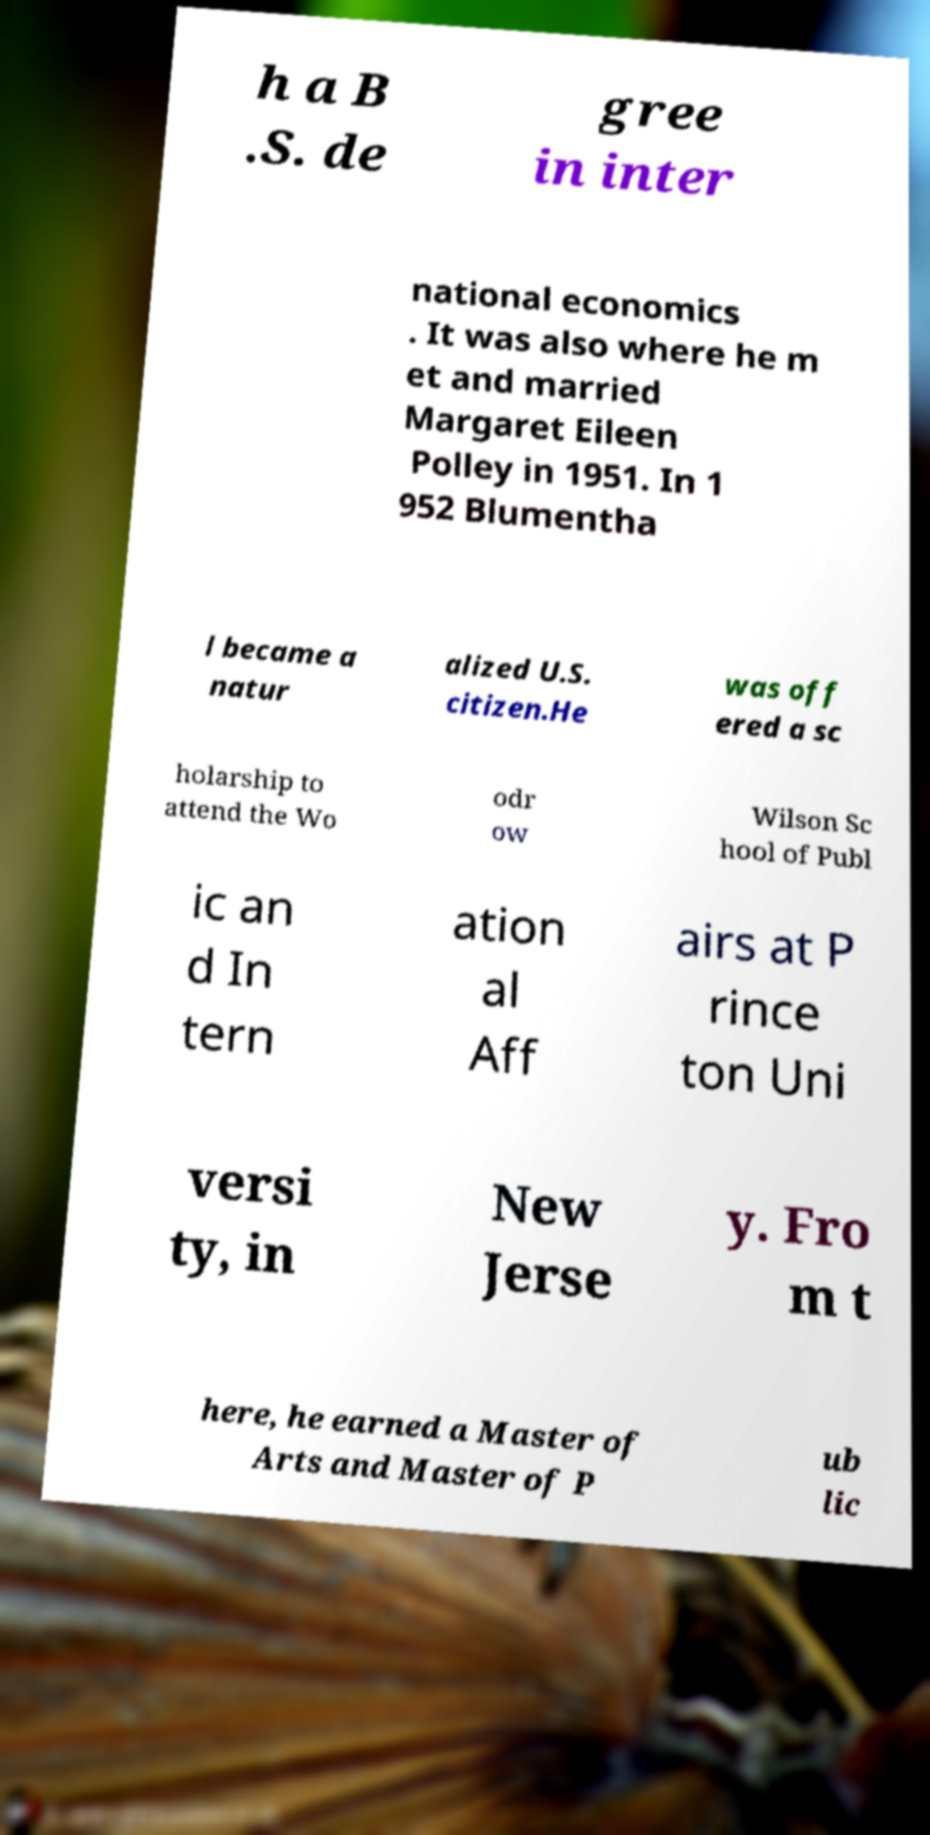Please identify and transcribe the text found in this image. h a B .S. de gree in inter national economics . It was also where he m et and married Margaret Eileen Polley in 1951. In 1 952 Blumentha l became a natur alized U.S. citizen.He was off ered a sc holarship to attend the Wo odr ow Wilson Sc hool of Publ ic an d In tern ation al Aff airs at P rince ton Uni versi ty, in New Jerse y. Fro m t here, he earned a Master of Arts and Master of P ub lic 